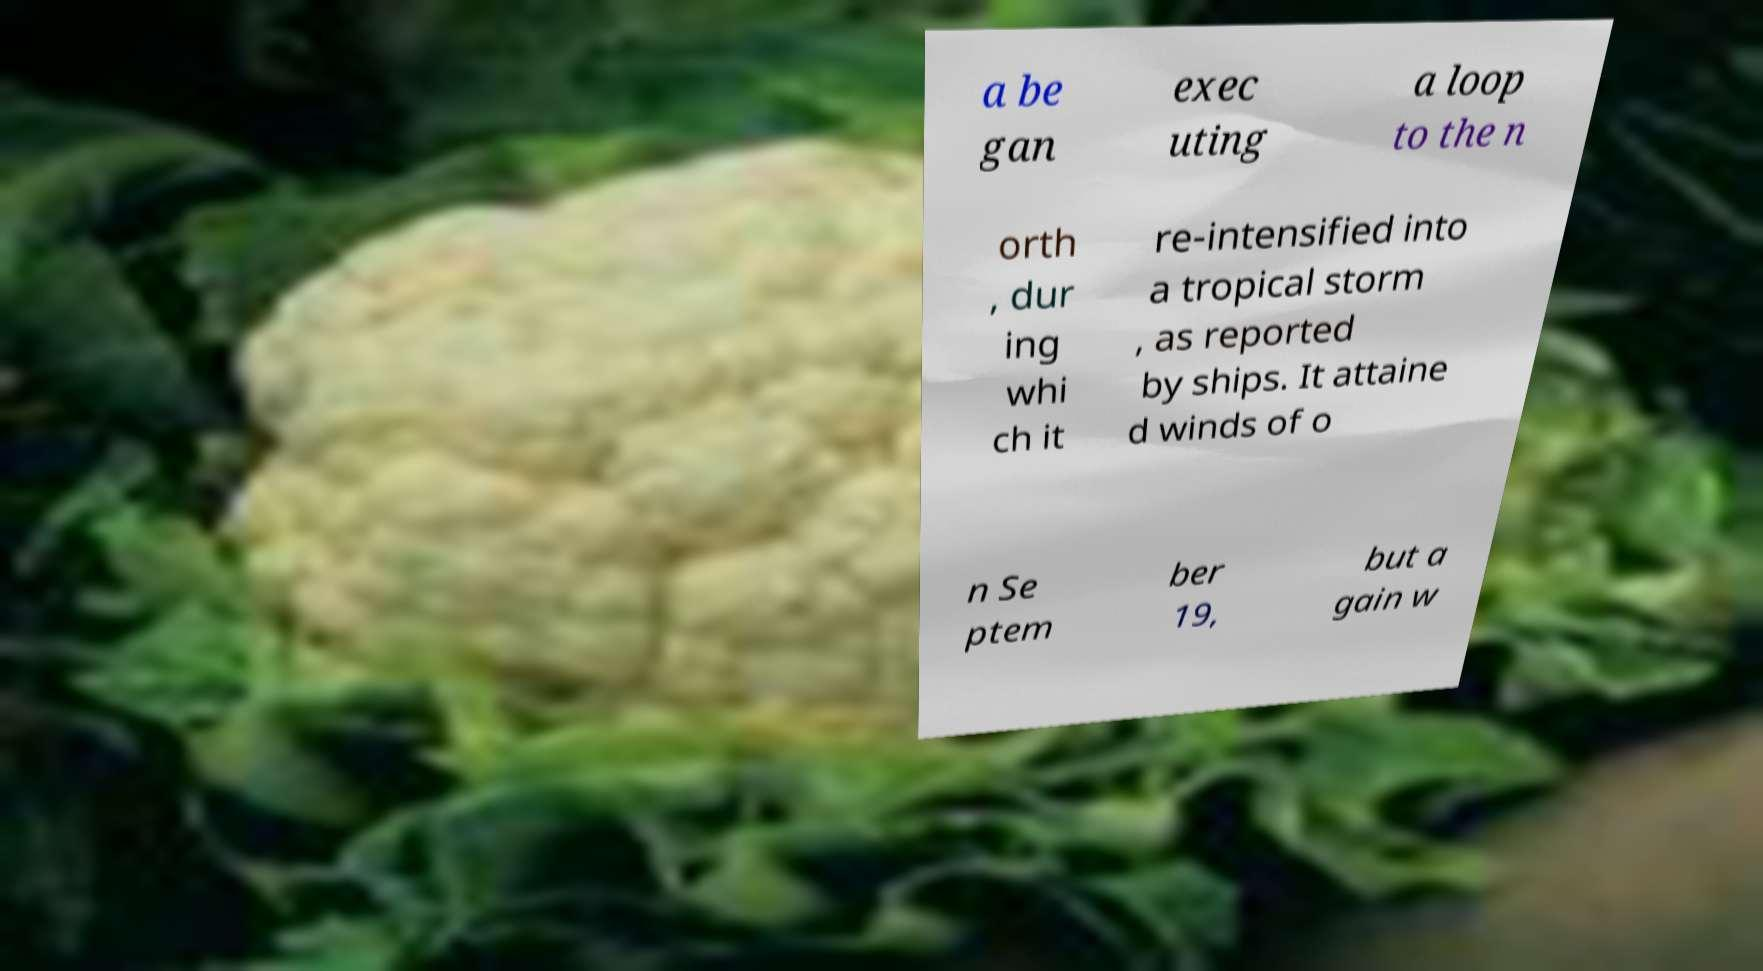What messages or text are displayed in this image? I need them in a readable, typed format. a be gan exec uting a loop to the n orth , dur ing whi ch it re-intensified into a tropical storm , as reported by ships. It attaine d winds of o n Se ptem ber 19, but a gain w 